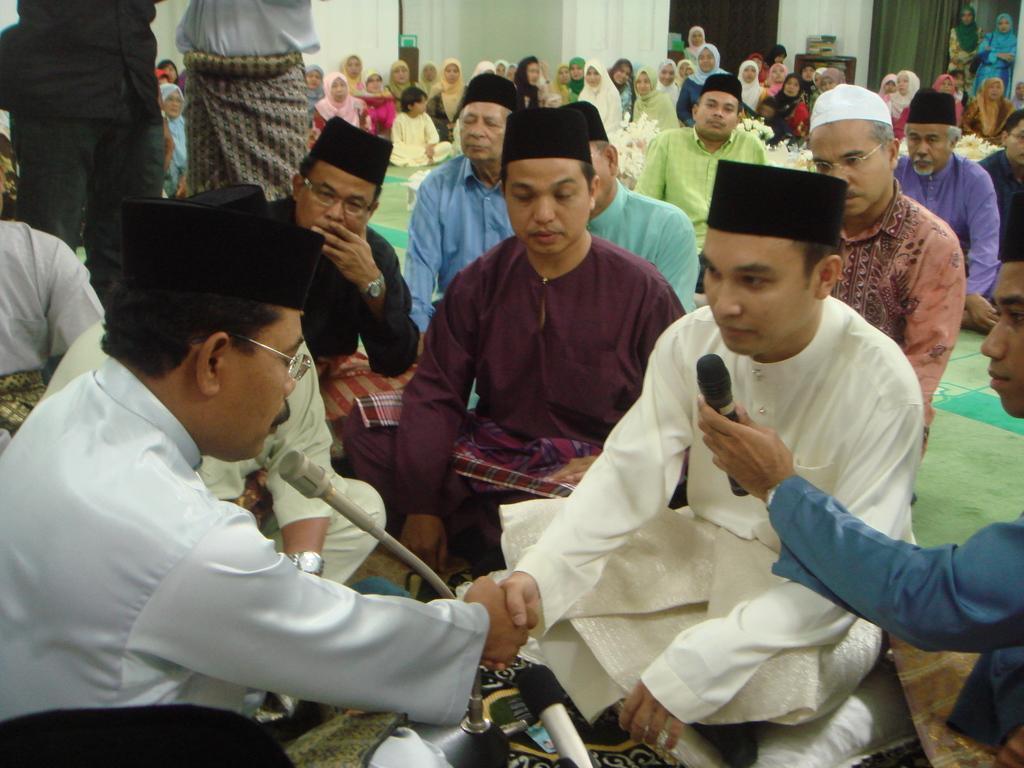Can you describe this image briefly? In this image people are sitting on the mat. At front there is a mike. At the back side there are curtains and we can see a table. On top of it there is an object. 